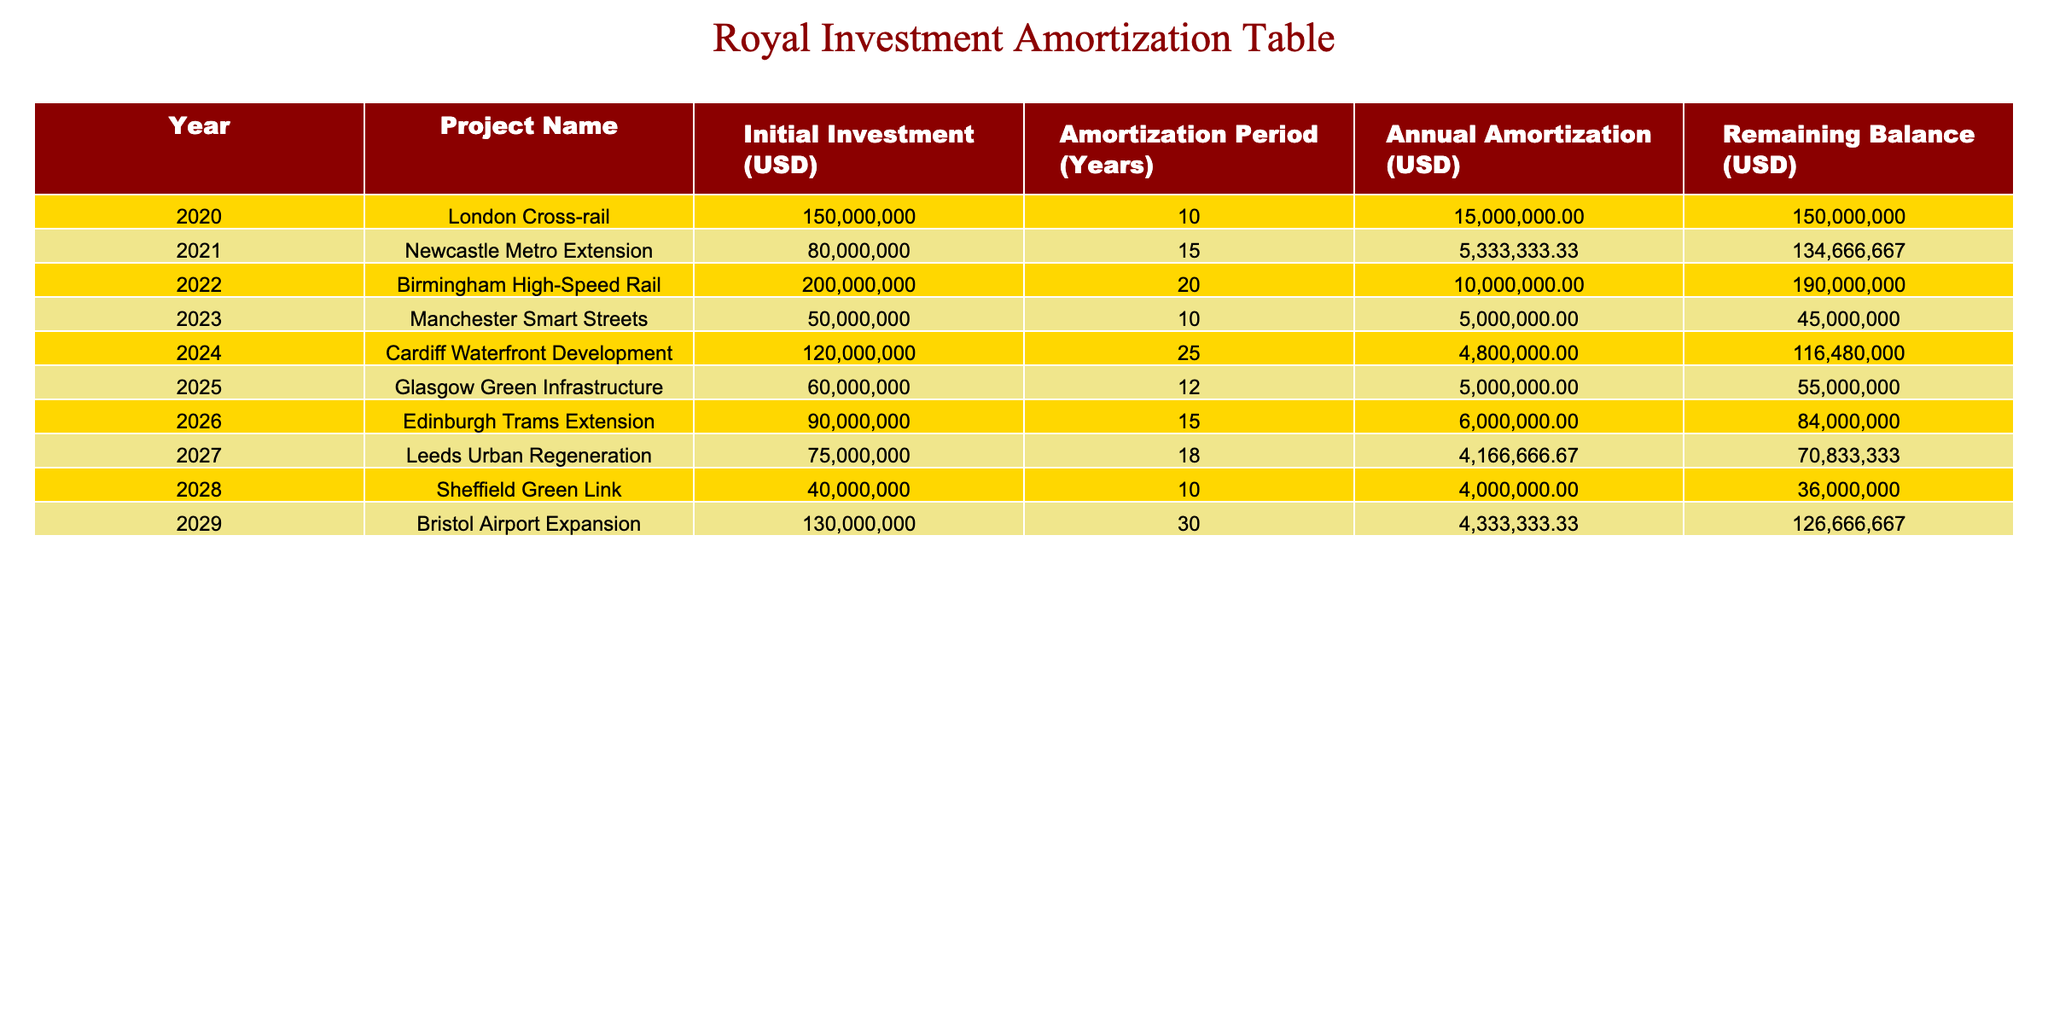What is the initial investment amount for the Birmingham High-Speed Rail project? The table lists the initial investment for the Birmingham High-Speed Rail project under the "Initial Investment (USD)" column. Referring to the table, the amount is 200000000 USD.
Answer: 200000000 Which project has the longest amortization period? The amortization period for each project is listed in the "Amortization Period (Years)" column. Upon reviewing the table, the Bristol Airport Expansion has the longest period at 30 years.
Answer: Bristol Airport Expansion What is the total annual amortization for all projects combined in 2021? To find the total annual amortization for 2021, I need to sum the annual amortizations of all projects in that year from the "Annual Amortization (USD)" column. Adding them gives: 15000000 + 5333333.33 + 10000000 + 5000000 + 4800000 + 5000000 + 6000000 + 4166666.67 + 4000000 + 4333333.33 = 50000000. Therefore, the total is 50000000 USD.
Answer: 50000000 Is the remaining balance for the Newcastle Metro Extension project lower than 130000000 USD? The "Remaining Balance (USD)" column for the Newcastle Metro Extension lists the amount as 134666667. Since 134666667 is greater than 130000000, the answer is no.
Answer: No What is the average annual amortization amount across all projects listed? First, I will identify all annual amortization amounts from the "Annual Amortization (USD)" column: 15000000, 5333333.33, 10000000, 5000000, 4800000, 5000000, 6000000, 4166666.67, 4000000, 4333333.33. Next, summing these figures gives 50000000. Counting the number of projects, there are 10 projects, so the average is 50000000 divided by 10, which equals 5000000.
Answer: 5000000 Which project, by year, had the highest remaining balance at the end of the year? By examining the "Remaining Balance (USD)" column for each project in the table, the highest amount noted is 190000000 for the Birmingham High-Speed Rail project in 2022. Therefore, this project had the highest remaining balance at that time.
Answer: Birmingham High-Speed Rail 